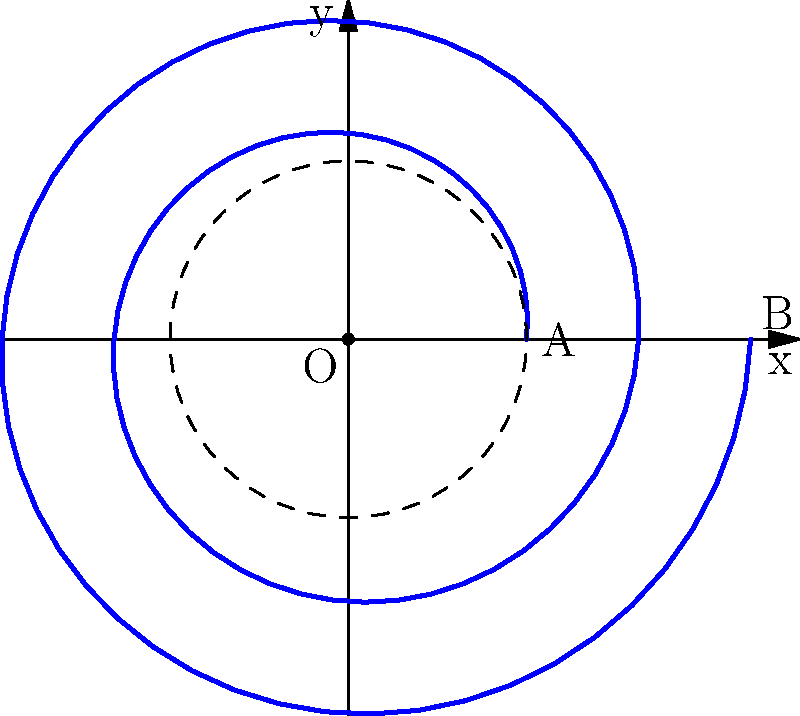A vinyl record's groove forms an Archimedean spiral starting at point A and ending at point B, as shown in the figure. The spiral is described by the equation $r = 1 + 0.1\theta$ (in inches), where $\theta$ is in radians and ranges from 0 to $4\pi$. Calculate the length of the groove to the nearest tenth of an inch. To find the arc length of the spiral, we'll use the arc length formula for polar curves:

$$L = \int_a^b \sqrt{r^2 + \left(\frac{dr}{d\theta}\right)^2} d\theta$$

Step 1: Determine $r$ and $\frac{dr}{d\theta}$
$r = 1 + 0.1\theta$
$\frac{dr}{d\theta} = 0.1$

Step 2: Substitute into the arc length formula
$$L = \int_0^{4\pi} \sqrt{(1 + 0.1\theta)^2 + (0.1)^2} d\theta$$

Step 3: Simplify the integrand
$$L = \int_0^{4\pi} \sqrt{1 + 0.2\theta + 0.01\theta^2 + 0.01} d\theta$$
$$L = \int_0^{4\pi} \sqrt{1.01 + 0.2\theta + 0.01\theta^2} d\theta$$

Step 4: This integral cannot be solved analytically, so we need to use numerical integration. Using a calculator or computer software, we can evaluate this integral:

$$L \approx 13.8511 \text{ inches}$$

Step 5: Rounding to the nearest tenth
$$L \approx 13.9 \text{ inches}$$
Answer: 13.9 inches 